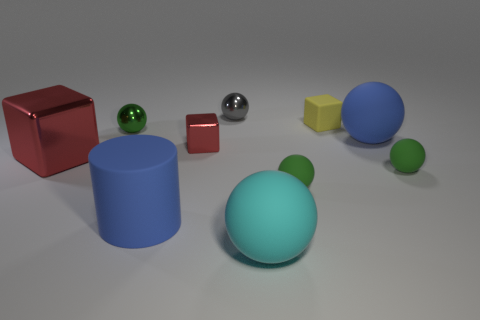There is a big ball that is the same color as the large cylinder; what material is it?
Offer a terse response. Rubber. Are there any other matte things of the same shape as the cyan rubber thing?
Your answer should be very brief. Yes. What number of other objects are there of the same shape as the big cyan rubber thing?
Your response must be concise. 5. What is the shape of the small object that is both behind the green shiny thing and in front of the tiny gray sphere?
Your answer should be very brief. Cube. How big is the blue object in front of the tiny red object?
Ensure brevity in your answer.  Large. Do the rubber cylinder and the gray metallic sphere have the same size?
Make the answer very short. No. Are there fewer small matte blocks that are left of the tiny rubber block than tiny green shiny balls that are behind the cyan thing?
Provide a succinct answer. Yes. There is a green sphere that is both right of the gray shiny ball and left of the tiny yellow cube; how big is it?
Offer a terse response. Small. There is a red thing that is on the left side of the tiny shiny sphere in front of the small gray metallic sphere; is there a big blue matte thing that is behind it?
Your response must be concise. Yes. Are there any tiny gray things?
Offer a terse response. Yes. 